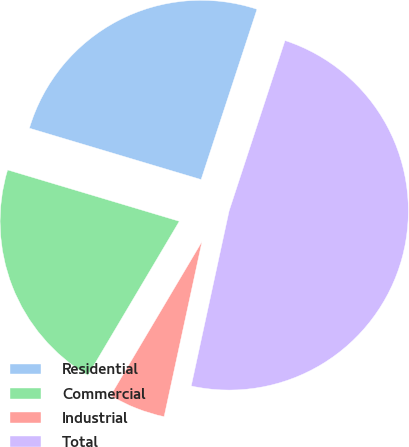Convert chart. <chart><loc_0><loc_0><loc_500><loc_500><pie_chart><fcel>Residential<fcel>Commercial<fcel>Industrial<fcel>Total<nl><fcel>25.42%<fcel>21.1%<fcel>5.13%<fcel>48.34%<nl></chart> 